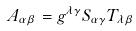<formula> <loc_0><loc_0><loc_500><loc_500>A _ { \alpha \beta } = g ^ { \lambda \gamma } S _ { \alpha \gamma } T _ { \lambda \beta }</formula> 